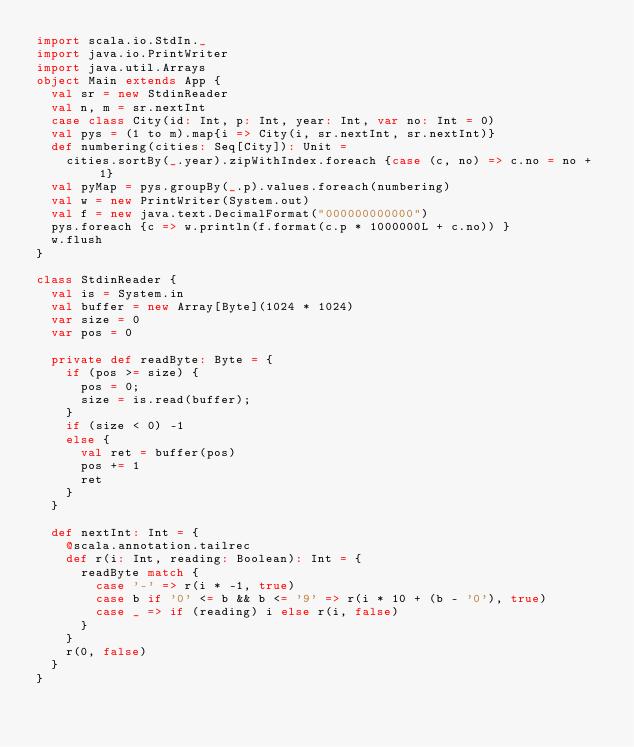<code> <loc_0><loc_0><loc_500><loc_500><_Scala_>import scala.io.StdIn._
import java.io.PrintWriter
import java.util.Arrays
object Main extends App {
  val sr = new StdinReader
  val n, m = sr.nextInt
  case class City(id: Int, p: Int, year: Int, var no: Int = 0)
  val pys = (1 to m).map{i => City(i, sr.nextInt, sr.nextInt)}
  def numbering(cities: Seq[City]): Unit =
    cities.sortBy(_.year).zipWithIndex.foreach {case (c, no) => c.no = no + 1}
  val pyMap = pys.groupBy(_.p).values.foreach(numbering)
  val w = new PrintWriter(System.out)
  val f = new java.text.DecimalFormat("000000000000")
  pys.foreach {c => w.println(f.format(c.p * 1000000L + c.no)) }
  w.flush
}

class StdinReader {
  val is = System.in
  val buffer = new Array[Byte](1024 * 1024)
  var size = 0
  var pos = 0

  private def readByte: Byte = {
    if (pos >= size) {
      pos = 0;
      size = is.read(buffer);
    }
    if (size < 0) -1
    else {
      val ret = buffer(pos)
      pos += 1
      ret
    }
  }

  def nextInt: Int = {
    @scala.annotation.tailrec
    def r(i: Int, reading: Boolean): Int = {
      readByte match {
        case '-' => r(i * -1, true)
        case b if '0' <= b && b <= '9' => r(i * 10 + (b - '0'), true)
        case _ => if (reading) i else r(i, false)
      }
    }
    r(0, false)
  }
}</code> 